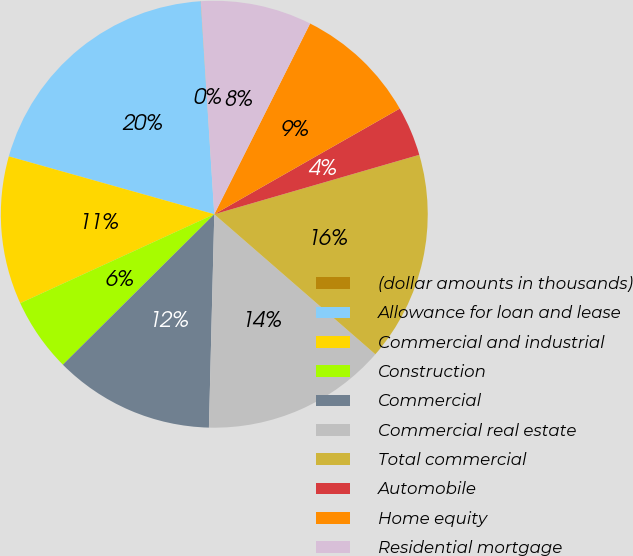Convert chart. <chart><loc_0><loc_0><loc_500><loc_500><pie_chart><fcel>(dollar amounts in thousands)<fcel>Allowance for loan and lease<fcel>Commercial and industrial<fcel>Construction<fcel>Commercial<fcel>Commercial real estate<fcel>Total commercial<fcel>Automobile<fcel>Home equity<fcel>Residential mortgage<nl><fcel>0.02%<fcel>19.61%<fcel>11.21%<fcel>5.61%<fcel>12.15%<fcel>14.01%<fcel>15.88%<fcel>3.75%<fcel>9.35%<fcel>8.41%<nl></chart> 